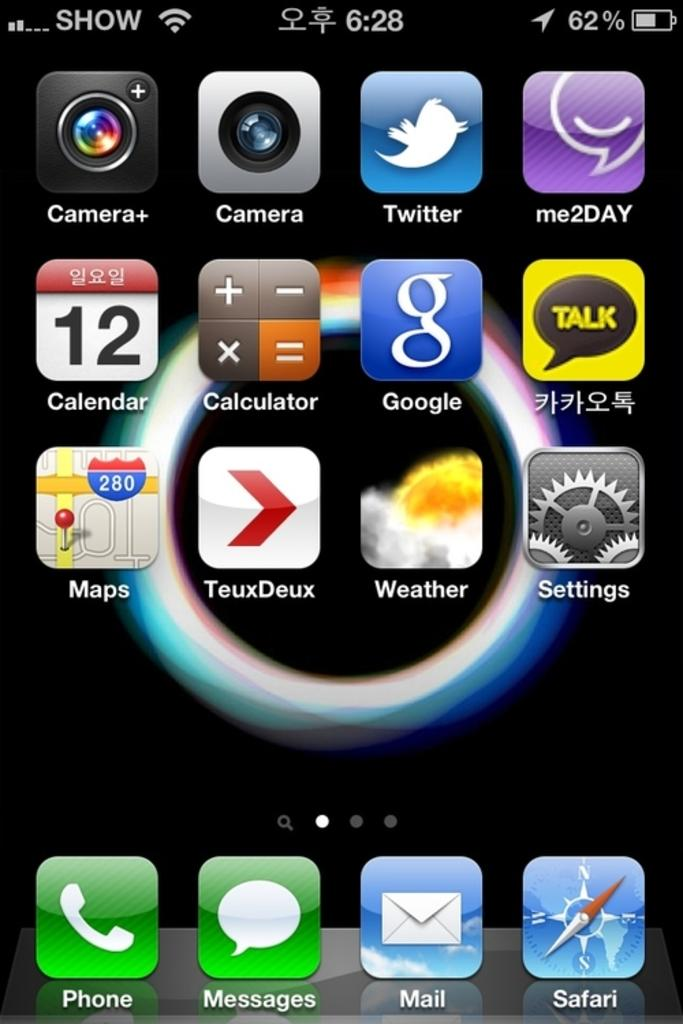<image>
Share a concise interpretation of the image provided. A screen shot of a smart device screen has many icons including camer, calculator, and maps and shows the time as 6:28. 